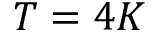Convert formula to latex. <formula><loc_0><loc_0><loc_500><loc_500>T = 4 K</formula> 